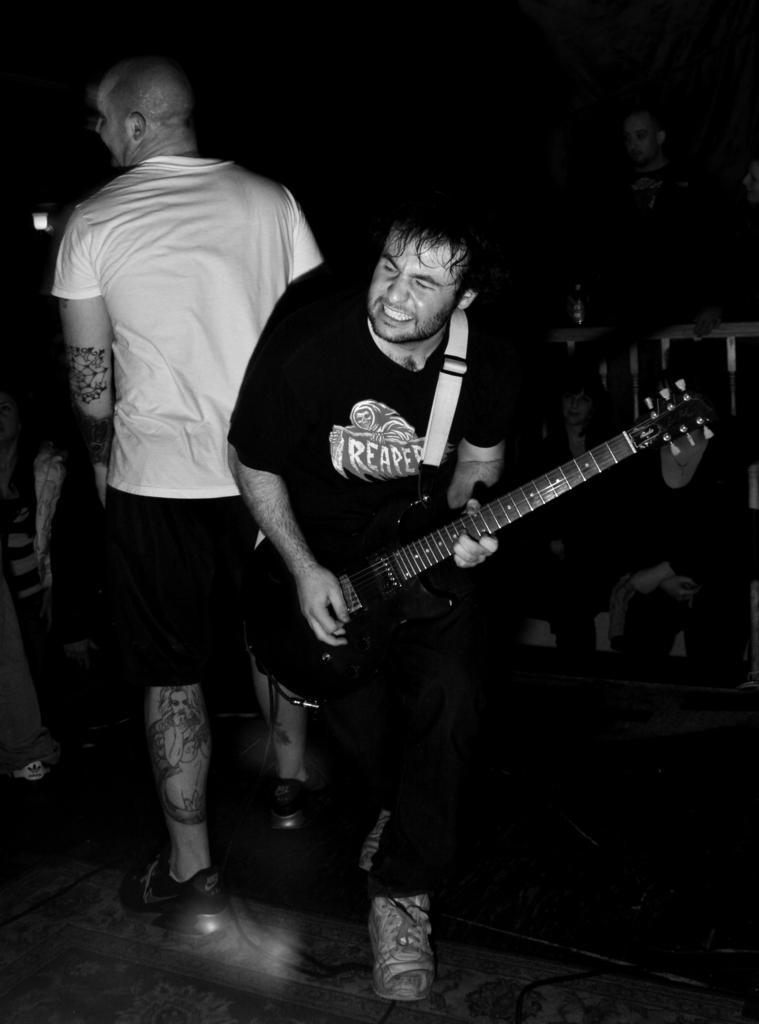Could you give a brief overview of what you see in this image? There is man standing in black costume playing guitar and behind him there is a man standing in white t shirt. 